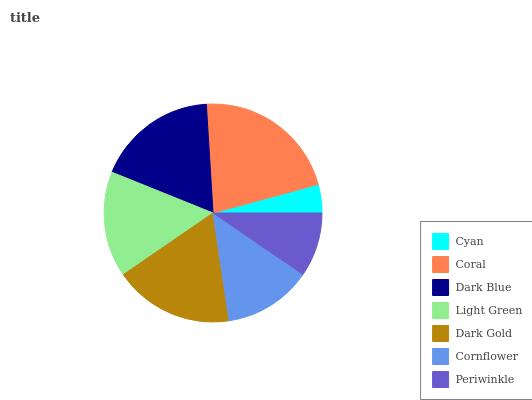Is Cyan the minimum?
Answer yes or no. Yes. Is Coral the maximum?
Answer yes or no. Yes. Is Dark Blue the minimum?
Answer yes or no. No. Is Dark Blue the maximum?
Answer yes or no. No. Is Coral greater than Dark Blue?
Answer yes or no. Yes. Is Dark Blue less than Coral?
Answer yes or no. Yes. Is Dark Blue greater than Coral?
Answer yes or no. No. Is Coral less than Dark Blue?
Answer yes or no. No. Is Light Green the high median?
Answer yes or no. Yes. Is Light Green the low median?
Answer yes or no. Yes. Is Cornflower the high median?
Answer yes or no. No. Is Cornflower the low median?
Answer yes or no. No. 